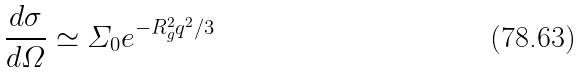<formula> <loc_0><loc_0><loc_500><loc_500>\frac { d \sigma } { d \varOmega } \simeq \varSigma _ { 0 } e ^ { - R _ { g } ^ { 2 } q ^ { 2 } / 3 }</formula> 